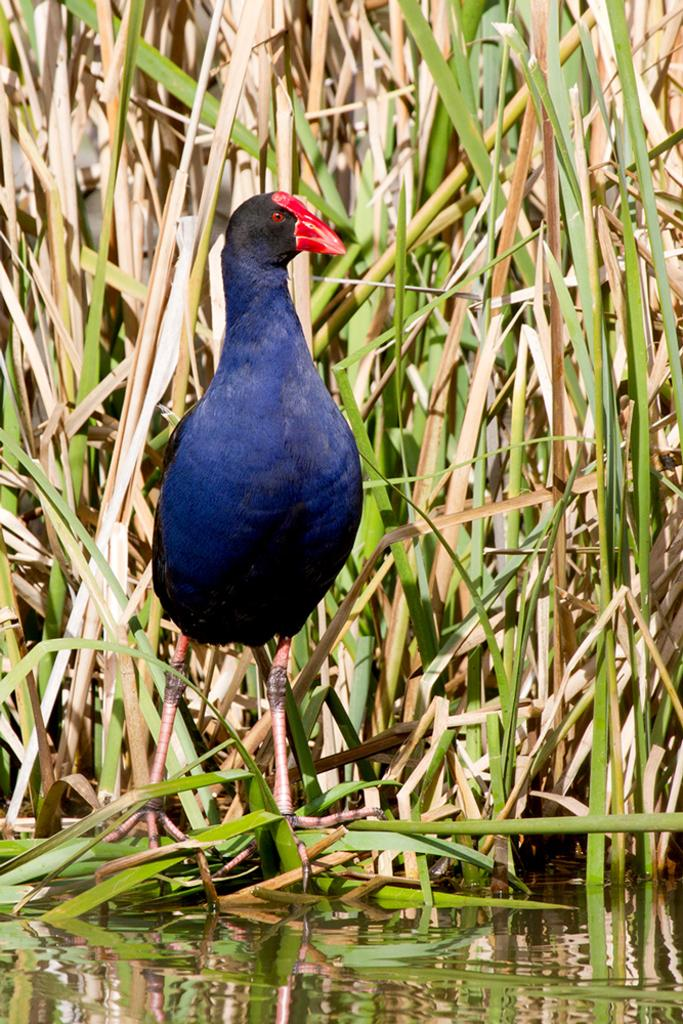What is the bird doing in the image? The bird is standing on the water in the image. What can be seen in the background of the image? There are planets visible in the background of the image. What type of environment is depicted in the image? There is water visible in the image. How many girls are wearing socks in the image? There are no girls or socks present in the image. 